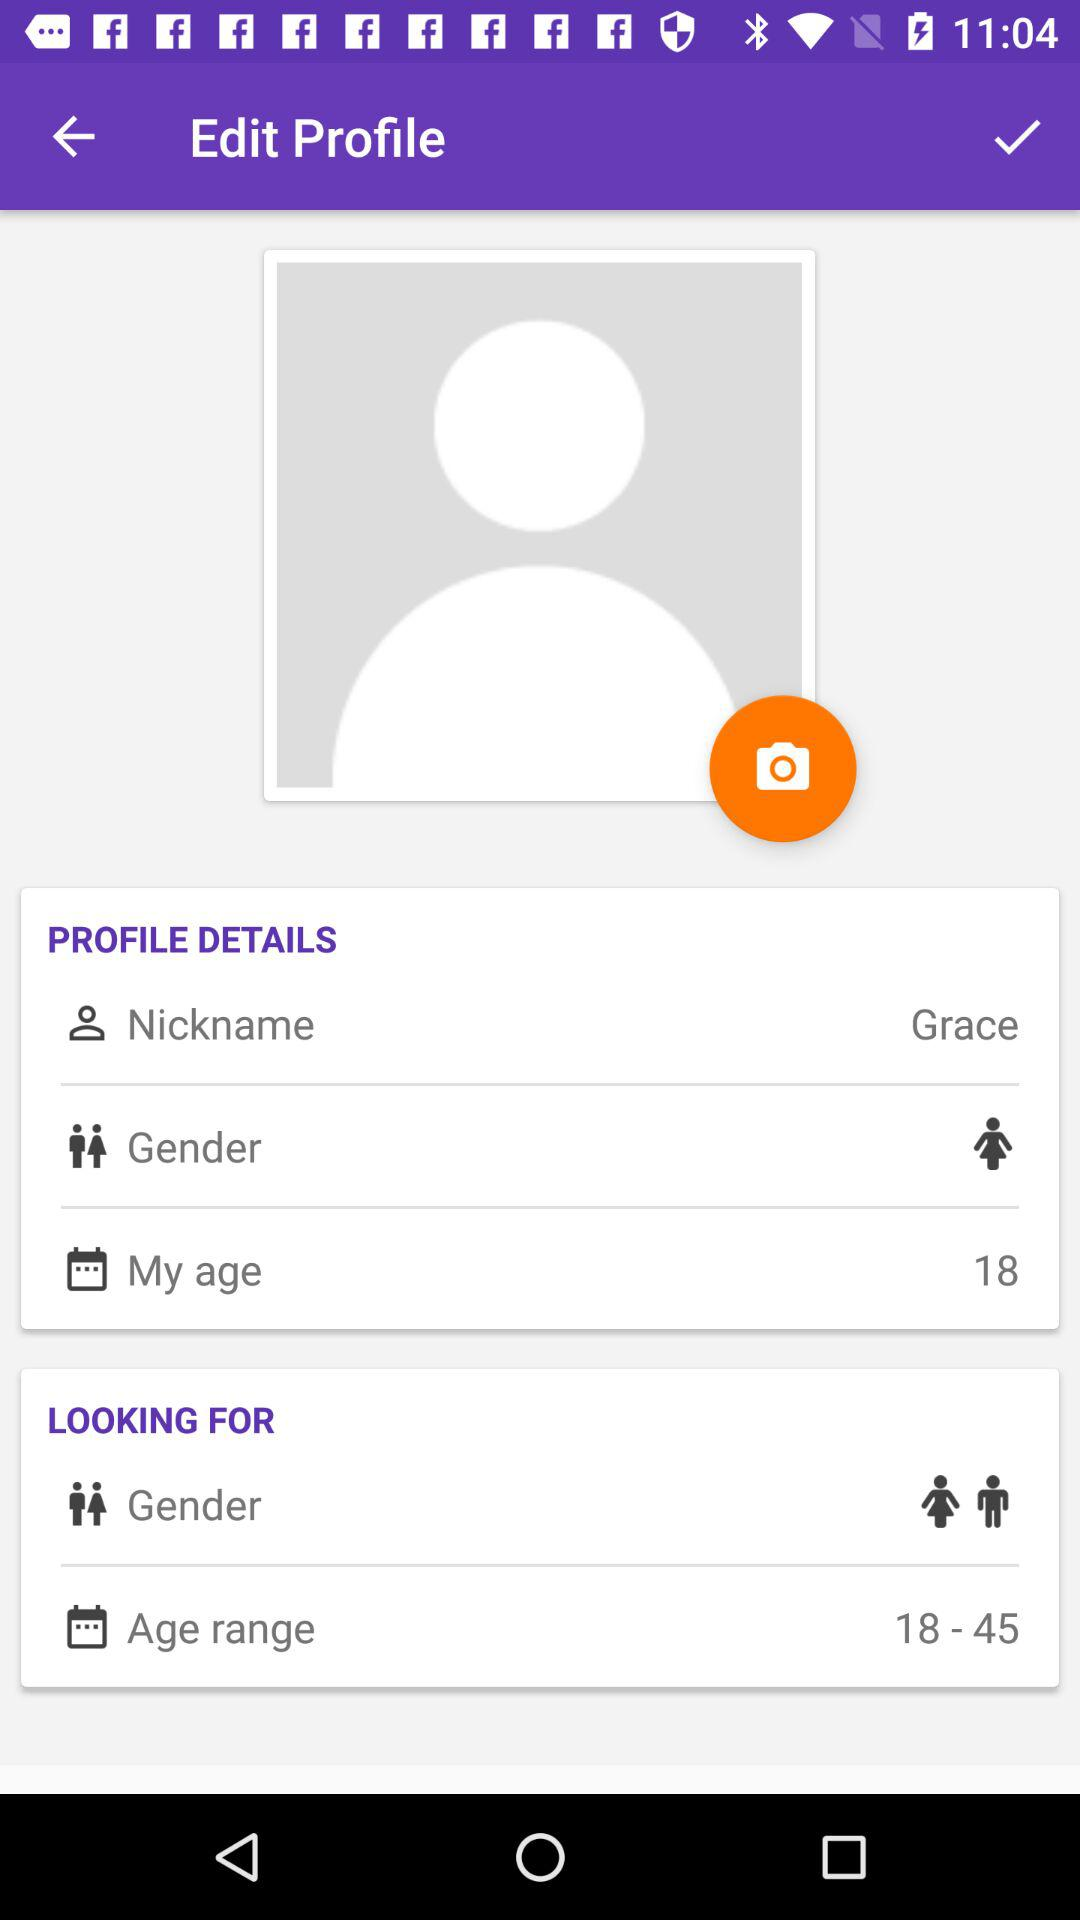What is the gender of the user? The gender of the user is female. 